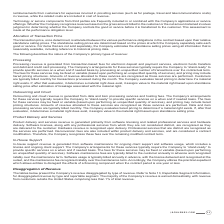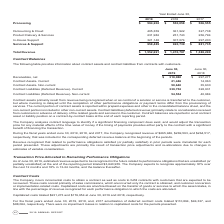According to Jack Henry Associates's financial document, What does the table present? the Company’s revenue disaggregated by type of revenue. The document states: "The tables below present the Company’s revenue disaggregated by type of revenue. Refer to Note 13, Reportable Segment Information, for disaggregated r..." Also, What are the types of revenue shown in the table? The document contains multiple relevant values: Processing, Outsourcing & Cloud, Product Delivery & Services, In-House Support, Services & Support. From the document: "In-House Support 321,148 307,074 297,203 Services & Support 958,489 920,739 $ 881,735 Processing Product Delivery & Services 231,982 251,743 256,794 O..." Also, What is the total revenue as of year ended June 30, 2019? According to the financial document, $1,552,691. The relevant text states: "Total Revenue $ 1,552,691 $ 1,470,797 $ 1,388,290..." Also, can you calculate: What is the average processing revenue for 2018 and 2019? To answer this question, I need to perform calculations using the financial data. The calculation is: ($594,202+$550,058)/2, which equals 572130. This is based on the information: "Processing $ 594,202 $ 550,058 $ 506,555 Processing $ 594,202 $ 550,058 $ 506,555..." The key data points involved are: 550,058, 594,202. Also, can you calculate: What is the average outsourcing & cloud revenue for 2018 and 2019? To answer this question, I need to perform calculations using the financial data. The calculation is: (405,359+361,922)/2, which equals 383640.5. This is based on the information: "Outsourcing & Cloud 405,359 361,922 327,738 Outsourcing & Cloud 405,359 361,922 327,738..." The key data points involved are: 361,922, 405,359. Also, can you calculate: What is the difference between the average processing revenue and the average outsourcing & cloud revenue for 2018-2019? To answer this question, I need to perform calculations using the financial data. The calculation is: [($594,202+$550,058)/2] - [(405,359+361,922)/2], which equals 188489.5. This is based on the information: "Outsourcing & Cloud 405,359 361,922 327,738 Processing $ 594,202 $ 550,058 $ 506,555 Outsourcing & Cloud 405,359 361,922 327,738 Processing $ 594,202 $ 550,058 $ 506,555 Processing $ 594,202 $ 550,058..." The key data points involved are: 2, 361,922, 405,359. 